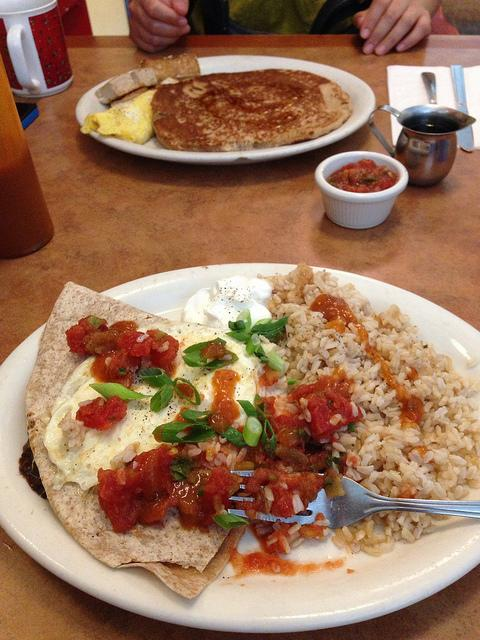What is the side dish on the plate in the foreground? Please explain your reasoning. rice. The mass of small tic-tac shaped grains on the right side of this plate is known as rice. 